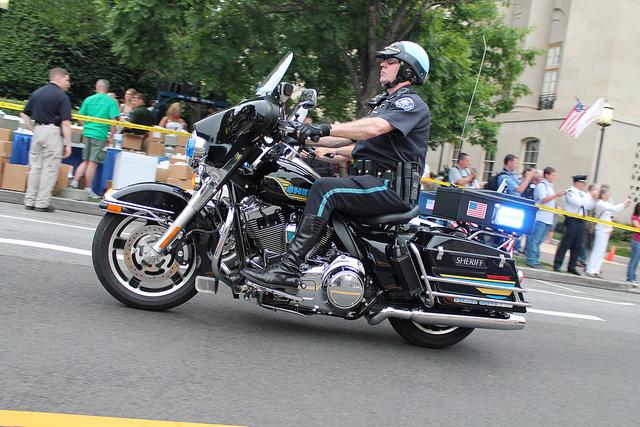What are the spectators doing?
Short answer required. Taking pictures. What color is the gas tank of the bike?
Write a very short answer. Black. What color are the man's shoes?
Be succinct. Black. Is he in a parade?
Give a very brief answer. Yes. What country's flags are on the motorcycle?
Keep it brief. Usa. Are they asian?
Short answer required. No. Are the people in the background taking pictures?
Concise answer only. Yes. How many yellow lines are on the road?
Write a very short answer. 1. Who rides the motorcycle?
Be succinct. Police. What is on the back of the closest bike?
Keep it brief. Flag. Is this police motorcycle in motion?
Keep it brief. Yes. What color is the motorcycle?
Keep it brief. Black. 